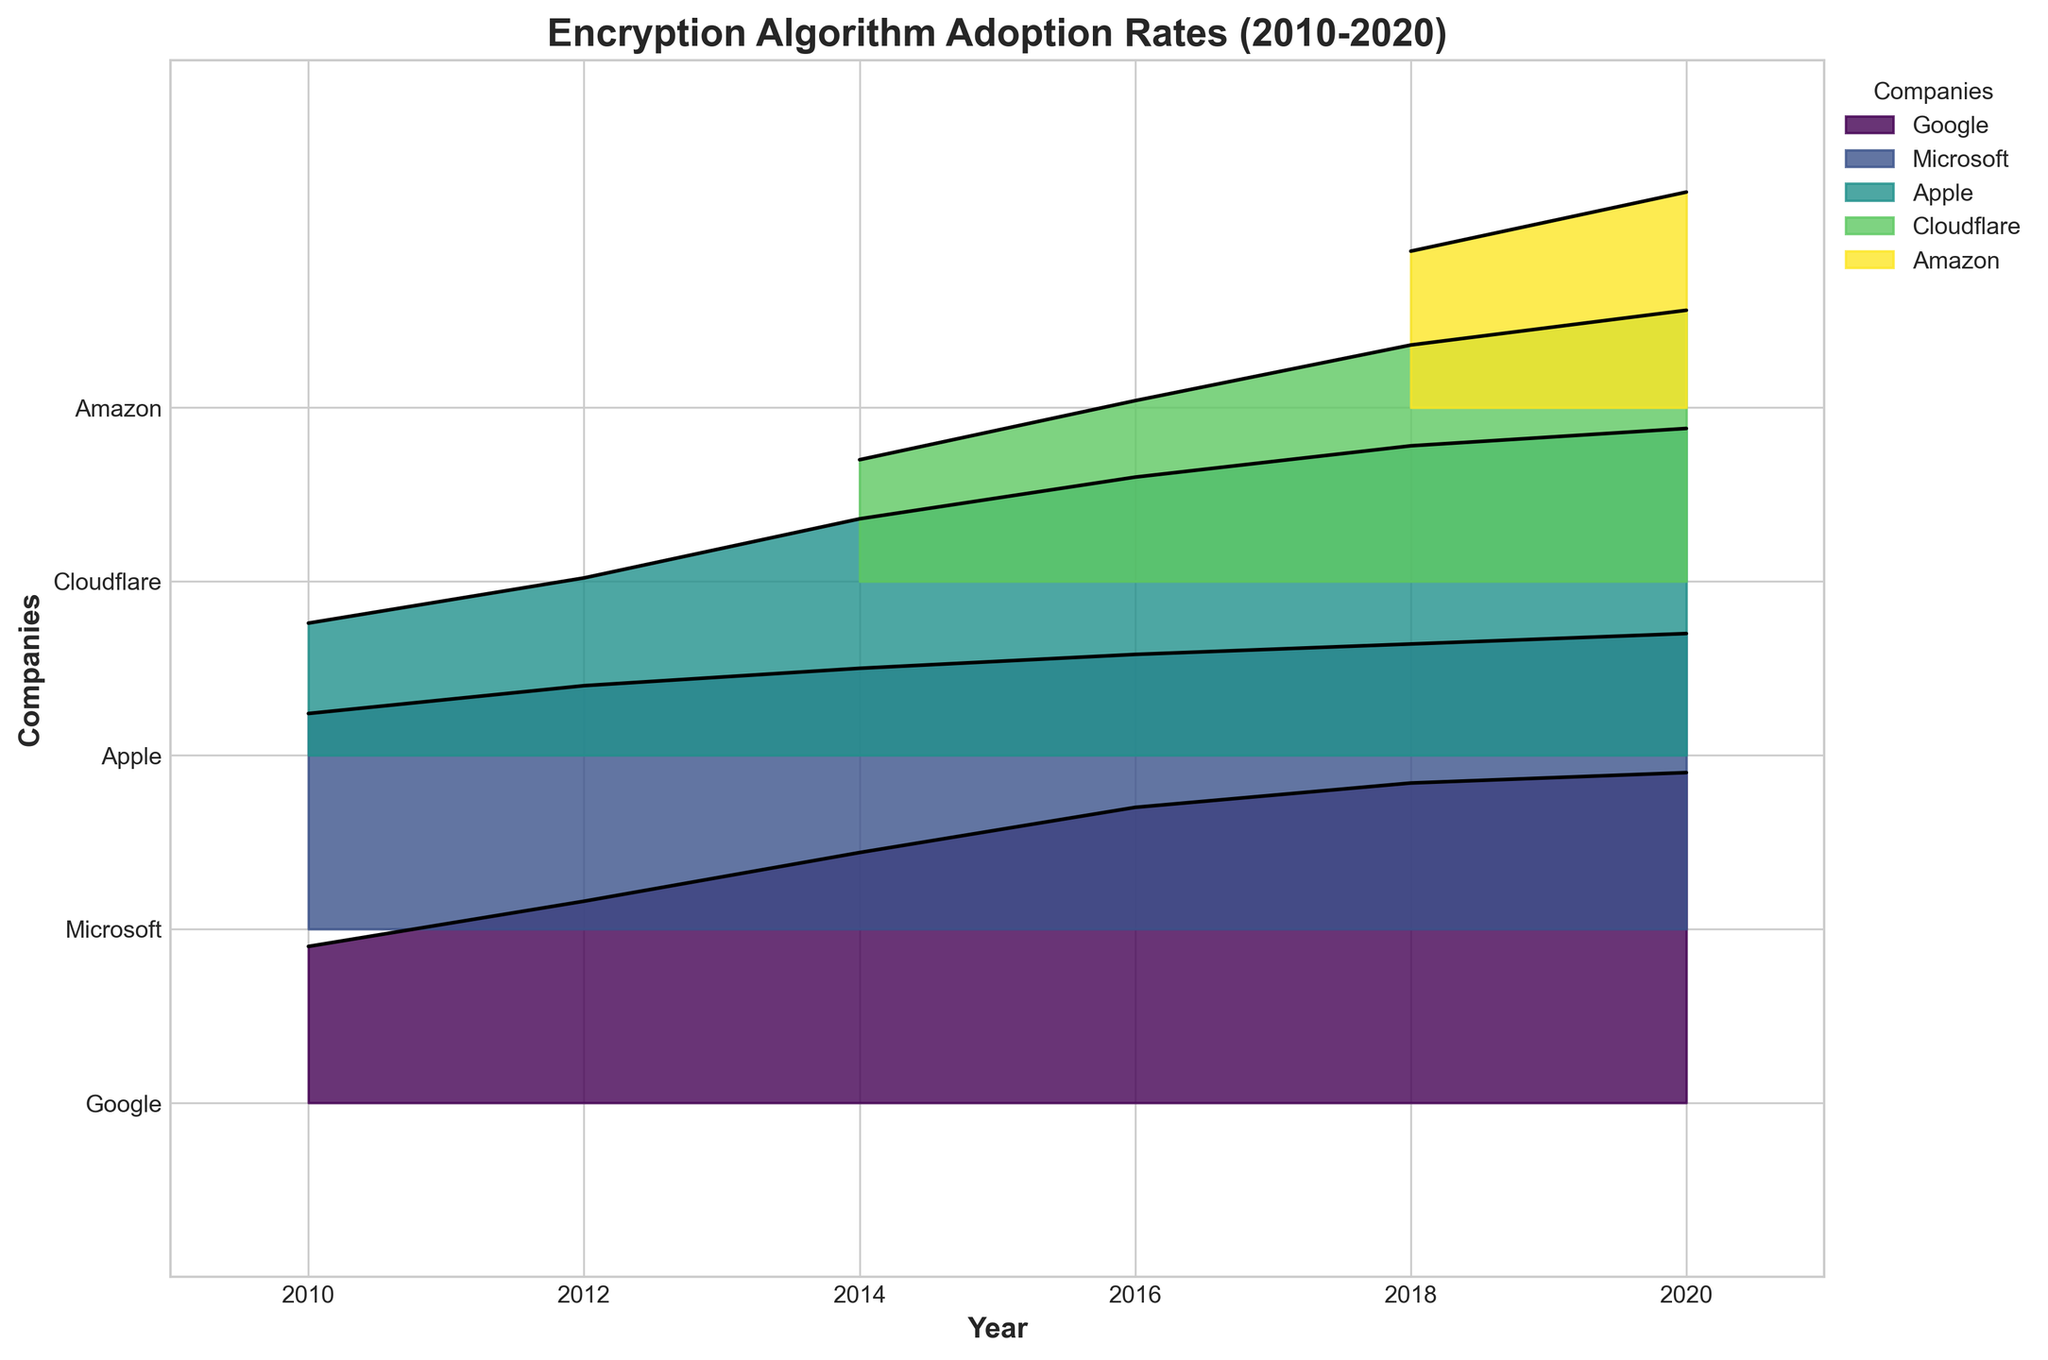what is the overall trend of the AES algorithm adoption rate for Google from 2010 to 2020? The adoption rate of the AES algorithm by Google increases steadily over the years. The adoption rate starts at 0.45 in 2010, rises to 0.58 in 2012, 0.72 in 2014, 0.85 in 2016, 0.92 in 2018, and reaches 0.95 in 2020.
Answer: The adoption rate increases Which company shows the most significant increase in adoption rate for the AES algorithm between 2010 and 2020? Comparing the adoption rates for the AES algorithm in 2010 and 2020 for each company, Google increases from 0.45 to 0.95 (0.50 increase), Apple from 0.38 to 0.94 (0.56 increase), and Microsoft does not use AES in 2010, so its increase is zero. Thus, Apple's adoption rate increase is the most significant.
Answer: Apple How does the adoption rate of RSA for Microsoft change from 2010 to 2020? From the plot, the adoption rate of RSA for Microsoft starts at 0.62 in 2010 and increases over the years: 0.70 in 2012, 0.75 in 2014, 0.79 in 2016, 0.82 in 2018, and reaches 0.85 in 2020.
Answer: It increases Between 2016 and 2020, which company's adoption rate for ChaCha20 increased the most? In 2016, Cloudflare's adoption rate for ChaCha20 is 0.52. By 2020, it increased to 0.78. Therefore, Cloudflare's adoption rate increase for ChaCha20 is 0.26 in these four years. There are no other companies adopting ChaCha20; hence, Cloudflare shows the most increase.
Answer: Cloudflare Which company had the highest adoption rate for the ECC algorithm in 2020? From the plot, Amazon is the only company listed with an ECC algorithm adoption rate in 2020, which is 0.62.
Answer: Amazon In 2014, how many companies are using the AES algorithm? From the plot, three companies are listed with an adoption rate for AES in 2014: Google, Microsoft, and Apple.
Answer: Three companies What is the difference in AES adoption rates between Apple and Google in 2016? The adoption rate for AES by Apple in 2016 is 0.80, and for Google is 0.85. The difference is 0.85 - 0.80 = 0.05.
Answer: 0.05 Which year shows the highest adoption rate for RSA by Microsoft? Examining the plot, the highest adoption rate for RSA by Microsoft is in 2020, with an adoption rate of 0.85.
Answer: 2020 